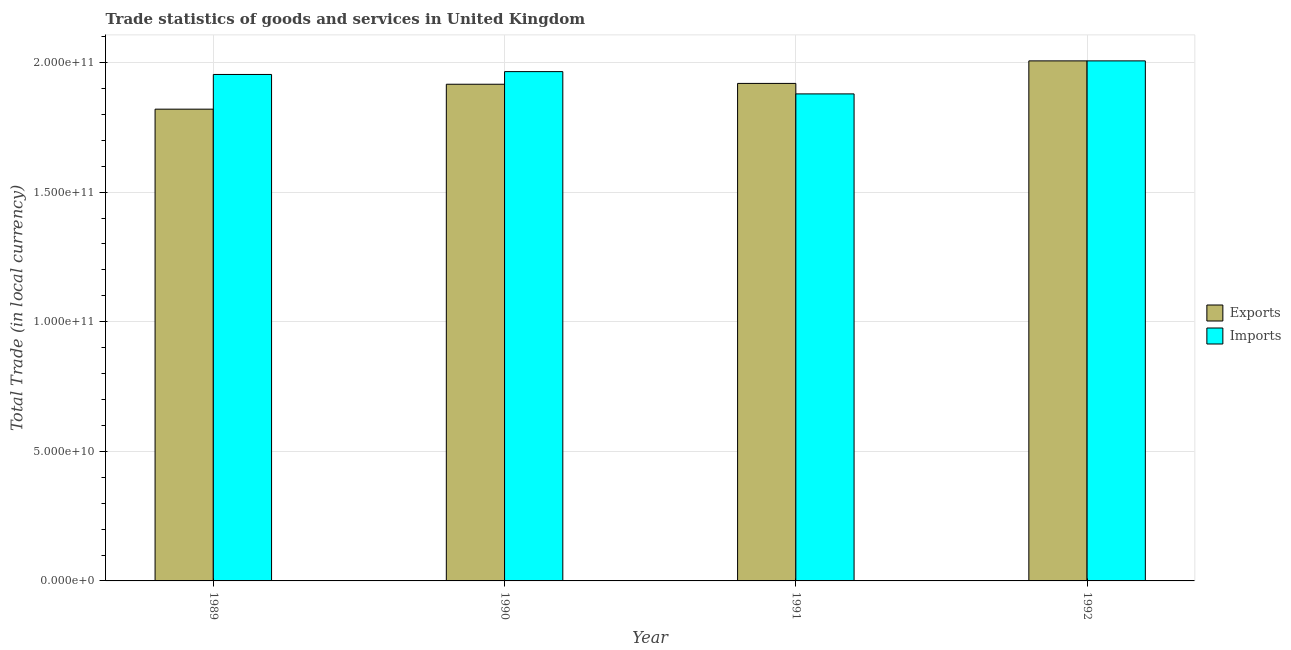How many different coloured bars are there?
Your response must be concise. 2. How many groups of bars are there?
Give a very brief answer. 4. How many bars are there on the 3rd tick from the left?
Give a very brief answer. 2. What is the label of the 3rd group of bars from the left?
Your answer should be very brief. 1991. In how many cases, is the number of bars for a given year not equal to the number of legend labels?
Provide a succinct answer. 0. What is the export of goods and services in 1990?
Your response must be concise. 1.92e+11. Across all years, what is the maximum export of goods and services?
Offer a very short reply. 2.01e+11. Across all years, what is the minimum export of goods and services?
Your answer should be very brief. 1.82e+11. In which year was the export of goods and services maximum?
Give a very brief answer. 1992. In which year was the export of goods and services minimum?
Provide a succinct answer. 1989. What is the total imports of goods and services in the graph?
Your answer should be very brief. 7.80e+11. What is the difference between the imports of goods and services in 1991 and that in 1992?
Provide a succinct answer. -1.27e+1. What is the difference between the imports of goods and services in 1990 and the export of goods and services in 1989?
Ensure brevity in your answer.  1.10e+09. What is the average imports of goods and services per year?
Keep it short and to the point. 1.95e+11. In the year 1990, what is the difference between the imports of goods and services and export of goods and services?
Provide a succinct answer. 0. In how many years, is the export of goods and services greater than 60000000000 LCU?
Keep it short and to the point. 4. What is the ratio of the imports of goods and services in 1989 to that in 1990?
Provide a short and direct response. 0.99. Is the imports of goods and services in 1990 less than that in 1991?
Your response must be concise. No. Is the difference between the export of goods and services in 1991 and 1992 greater than the difference between the imports of goods and services in 1991 and 1992?
Offer a terse response. No. What is the difference between the highest and the second highest export of goods and services?
Make the answer very short. 8.69e+09. What is the difference between the highest and the lowest export of goods and services?
Provide a succinct answer. 1.86e+1. Is the sum of the imports of goods and services in 1989 and 1991 greater than the maximum export of goods and services across all years?
Offer a terse response. Yes. What does the 2nd bar from the left in 1992 represents?
Provide a succinct answer. Imports. What does the 1st bar from the right in 1992 represents?
Your answer should be compact. Imports. Are all the bars in the graph horizontal?
Offer a very short reply. No. Does the graph contain any zero values?
Provide a short and direct response. No. Where does the legend appear in the graph?
Offer a very short reply. Center right. How many legend labels are there?
Ensure brevity in your answer.  2. How are the legend labels stacked?
Your response must be concise. Vertical. What is the title of the graph?
Provide a succinct answer. Trade statistics of goods and services in United Kingdom. Does "Secondary school" appear as one of the legend labels in the graph?
Your answer should be very brief. No. What is the label or title of the Y-axis?
Make the answer very short. Total Trade (in local currency). What is the Total Trade (in local currency) of Exports in 1989?
Give a very brief answer. 1.82e+11. What is the Total Trade (in local currency) of Imports in 1989?
Offer a terse response. 1.95e+11. What is the Total Trade (in local currency) of Exports in 1990?
Ensure brevity in your answer.  1.92e+11. What is the Total Trade (in local currency) in Imports in 1990?
Provide a succinct answer. 1.96e+11. What is the Total Trade (in local currency) in Exports in 1991?
Give a very brief answer. 1.92e+11. What is the Total Trade (in local currency) in Imports in 1991?
Your answer should be very brief. 1.88e+11. What is the Total Trade (in local currency) of Exports in 1992?
Offer a very short reply. 2.01e+11. What is the Total Trade (in local currency) in Imports in 1992?
Provide a short and direct response. 2.01e+11. Across all years, what is the maximum Total Trade (in local currency) of Exports?
Offer a terse response. 2.01e+11. Across all years, what is the maximum Total Trade (in local currency) in Imports?
Your response must be concise. 2.01e+11. Across all years, what is the minimum Total Trade (in local currency) in Exports?
Offer a terse response. 1.82e+11. Across all years, what is the minimum Total Trade (in local currency) of Imports?
Offer a terse response. 1.88e+11. What is the total Total Trade (in local currency) in Exports in the graph?
Give a very brief answer. 7.66e+11. What is the total Total Trade (in local currency) of Imports in the graph?
Provide a short and direct response. 7.80e+11. What is the difference between the Total Trade (in local currency) in Exports in 1989 and that in 1990?
Your answer should be very brief. -9.61e+09. What is the difference between the Total Trade (in local currency) in Imports in 1989 and that in 1990?
Give a very brief answer. -1.10e+09. What is the difference between the Total Trade (in local currency) of Exports in 1989 and that in 1991?
Your answer should be very brief. -9.93e+09. What is the difference between the Total Trade (in local currency) in Imports in 1989 and that in 1991?
Provide a succinct answer. 7.50e+09. What is the difference between the Total Trade (in local currency) in Exports in 1989 and that in 1992?
Keep it short and to the point. -1.86e+1. What is the difference between the Total Trade (in local currency) of Imports in 1989 and that in 1992?
Provide a succinct answer. -5.24e+09. What is the difference between the Total Trade (in local currency) of Exports in 1990 and that in 1991?
Make the answer very short. -3.18e+08. What is the difference between the Total Trade (in local currency) in Imports in 1990 and that in 1991?
Make the answer very short. 8.60e+09. What is the difference between the Total Trade (in local currency) in Exports in 1990 and that in 1992?
Your answer should be compact. -9.01e+09. What is the difference between the Total Trade (in local currency) of Imports in 1990 and that in 1992?
Keep it short and to the point. -4.14e+09. What is the difference between the Total Trade (in local currency) in Exports in 1991 and that in 1992?
Your answer should be very brief. -8.69e+09. What is the difference between the Total Trade (in local currency) in Imports in 1991 and that in 1992?
Keep it short and to the point. -1.27e+1. What is the difference between the Total Trade (in local currency) in Exports in 1989 and the Total Trade (in local currency) in Imports in 1990?
Provide a succinct answer. -1.45e+1. What is the difference between the Total Trade (in local currency) of Exports in 1989 and the Total Trade (in local currency) of Imports in 1991?
Your answer should be very brief. -5.89e+09. What is the difference between the Total Trade (in local currency) in Exports in 1989 and the Total Trade (in local currency) in Imports in 1992?
Keep it short and to the point. -1.86e+1. What is the difference between the Total Trade (in local currency) in Exports in 1990 and the Total Trade (in local currency) in Imports in 1991?
Your answer should be very brief. 3.73e+09. What is the difference between the Total Trade (in local currency) in Exports in 1990 and the Total Trade (in local currency) in Imports in 1992?
Provide a succinct answer. -9.02e+09. What is the difference between the Total Trade (in local currency) of Exports in 1991 and the Total Trade (in local currency) of Imports in 1992?
Ensure brevity in your answer.  -8.70e+09. What is the average Total Trade (in local currency) of Exports per year?
Offer a very short reply. 1.92e+11. What is the average Total Trade (in local currency) in Imports per year?
Ensure brevity in your answer.  1.95e+11. In the year 1989, what is the difference between the Total Trade (in local currency) of Exports and Total Trade (in local currency) of Imports?
Make the answer very short. -1.34e+1. In the year 1990, what is the difference between the Total Trade (in local currency) in Exports and Total Trade (in local currency) in Imports?
Provide a short and direct response. -4.87e+09. In the year 1991, what is the difference between the Total Trade (in local currency) in Exports and Total Trade (in local currency) in Imports?
Your answer should be very brief. 4.04e+09. In the year 1992, what is the difference between the Total Trade (in local currency) in Exports and Total Trade (in local currency) in Imports?
Your answer should be compact. -3.24e+06. What is the ratio of the Total Trade (in local currency) of Exports in 1989 to that in 1990?
Make the answer very short. 0.95. What is the ratio of the Total Trade (in local currency) in Imports in 1989 to that in 1990?
Provide a short and direct response. 0.99. What is the ratio of the Total Trade (in local currency) of Exports in 1989 to that in 1991?
Give a very brief answer. 0.95. What is the ratio of the Total Trade (in local currency) in Imports in 1989 to that in 1991?
Your response must be concise. 1.04. What is the ratio of the Total Trade (in local currency) in Exports in 1989 to that in 1992?
Offer a very short reply. 0.91. What is the ratio of the Total Trade (in local currency) of Imports in 1989 to that in 1992?
Provide a short and direct response. 0.97. What is the ratio of the Total Trade (in local currency) of Exports in 1990 to that in 1991?
Provide a succinct answer. 1. What is the ratio of the Total Trade (in local currency) of Imports in 1990 to that in 1991?
Offer a terse response. 1.05. What is the ratio of the Total Trade (in local currency) of Exports in 1990 to that in 1992?
Provide a short and direct response. 0.96. What is the ratio of the Total Trade (in local currency) in Imports in 1990 to that in 1992?
Your answer should be very brief. 0.98. What is the ratio of the Total Trade (in local currency) of Exports in 1991 to that in 1992?
Provide a short and direct response. 0.96. What is the ratio of the Total Trade (in local currency) in Imports in 1991 to that in 1992?
Keep it short and to the point. 0.94. What is the difference between the highest and the second highest Total Trade (in local currency) of Exports?
Provide a succinct answer. 8.69e+09. What is the difference between the highest and the second highest Total Trade (in local currency) in Imports?
Give a very brief answer. 4.14e+09. What is the difference between the highest and the lowest Total Trade (in local currency) of Exports?
Offer a terse response. 1.86e+1. What is the difference between the highest and the lowest Total Trade (in local currency) of Imports?
Your answer should be very brief. 1.27e+1. 